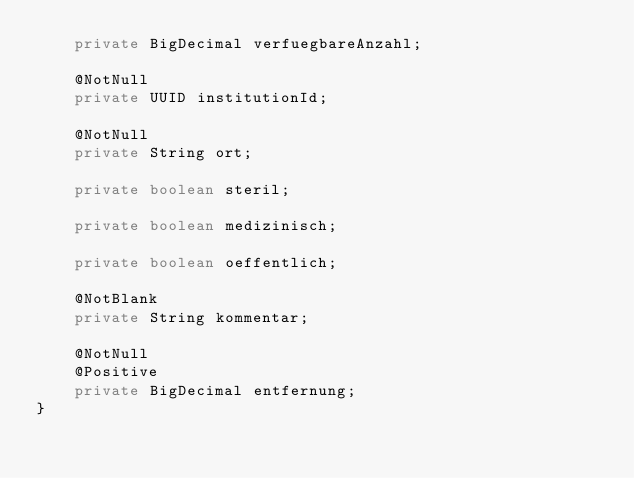<code> <loc_0><loc_0><loc_500><loc_500><_Java_>    private BigDecimal verfuegbareAnzahl;

    @NotNull
    private UUID institutionId;

    @NotNull
    private String ort;

    private boolean steril;

    private boolean medizinisch;

    private boolean oeffentlich;

    @NotBlank
    private String kommentar;

    @NotNull
    @Positive
    private BigDecimal entfernung;
}
</code> 